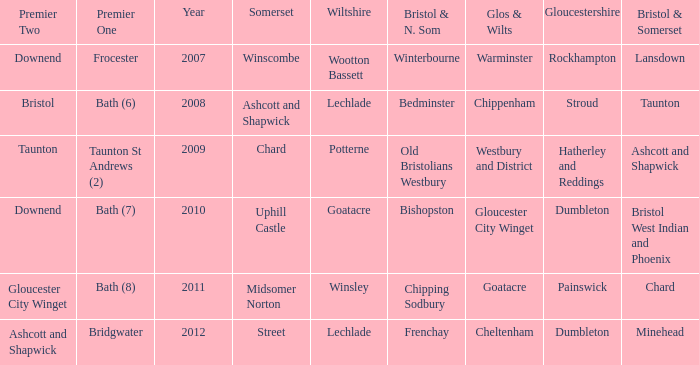Could you parse the entire table? {'header': ['Premier Two', 'Premier One', 'Year', 'Somerset', 'Wiltshire', 'Bristol & N. Som', 'Glos & Wilts', 'Gloucestershire', 'Bristol & Somerset'], 'rows': [['Downend', 'Frocester', '2007', 'Winscombe', 'Wootton Bassett', 'Winterbourne', 'Warminster', 'Rockhampton', 'Lansdown'], ['Bristol', 'Bath (6)', '2008', 'Ashcott and Shapwick', 'Lechlade', 'Bedminster', 'Chippenham', 'Stroud', 'Taunton'], ['Taunton', 'Taunton St Andrews (2)', '2009', 'Chard', 'Potterne', 'Old Bristolians Westbury', 'Westbury and District', 'Hatherley and Reddings', 'Ashcott and Shapwick'], ['Downend', 'Bath (7)', '2010', 'Uphill Castle', 'Goatacre', 'Bishopston', 'Gloucester City Winget', 'Dumbleton', 'Bristol West Indian and Phoenix'], ['Gloucester City Winget', 'Bath (8)', '2011', 'Midsomer Norton', 'Winsley', 'Chipping Sodbury', 'Goatacre', 'Painswick', 'Chard'], ['Ashcott and Shapwick', 'Bridgwater', '2012', 'Street', 'Lechlade', 'Frenchay', 'Cheltenham', 'Dumbleton', 'Minehead']]} What is the bristol & n. som where the somerset is ashcott and shapwick? Bedminster. 